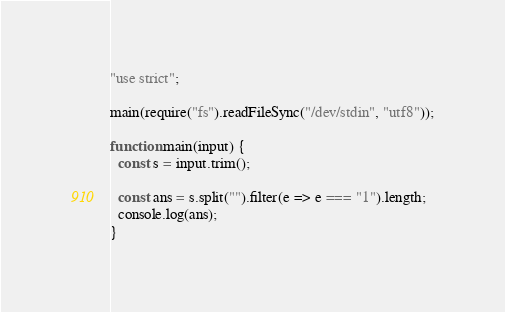<code> <loc_0><loc_0><loc_500><loc_500><_TypeScript_>"use strict";

main(require("fs").readFileSync("/dev/stdin", "utf8"));

function main(input) {
  const s = input.trim();

  const ans = s.split("").filter(e => e === "1").length;
  console.log(ans);
}</code> 